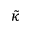Convert formula to latex. <formula><loc_0><loc_0><loc_500><loc_500>\tilde { \kappa }</formula> 